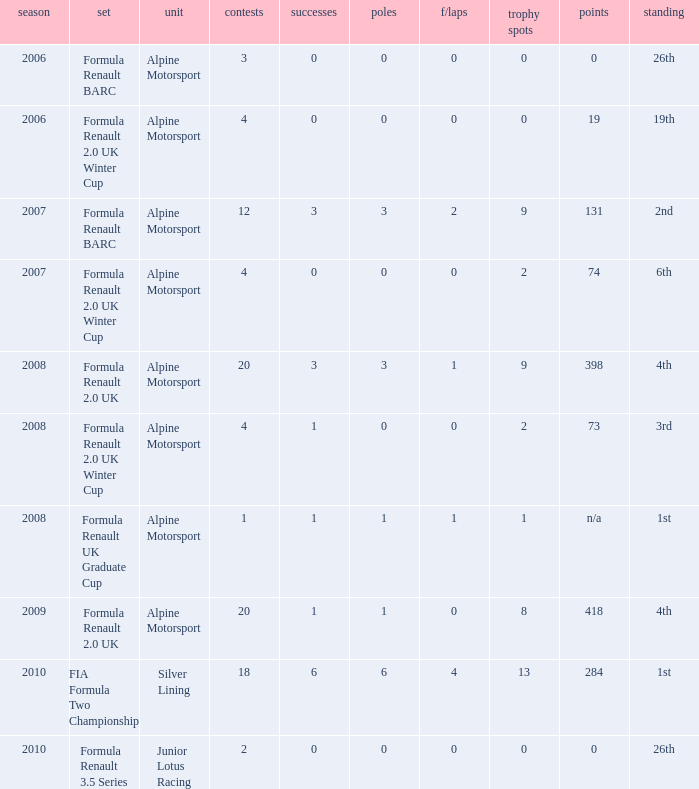What races achieved 0 f/laps and 1 pole position? 20.0. 